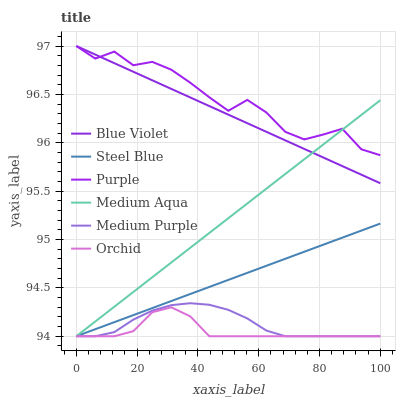Does Orchid have the minimum area under the curve?
Answer yes or no. Yes. Does Purple have the maximum area under the curve?
Answer yes or no. Yes. Does Steel Blue have the minimum area under the curve?
Answer yes or no. No. Does Steel Blue have the maximum area under the curve?
Answer yes or no. No. Is Medium Aqua the smoothest?
Answer yes or no. Yes. Is Purple the roughest?
Answer yes or no. Yes. Is Steel Blue the smoothest?
Answer yes or no. No. Is Steel Blue the roughest?
Answer yes or no. No. Does Blue Violet have the lowest value?
Answer yes or no. No. Does Blue Violet have the highest value?
Answer yes or no. Yes. Does Steel Blue have the highest value?
Answer yes or no. No. Is Steel Blue less than Purple?
Answer yes or no. Yes. Is Purple greater than Orchid?
Answer yes or no. Yes. Does Steel Blue intersect Medium Aqua?
Answer yes or no. Yes. Is Steel Blue less than Medium Aqua?
Answer yes or no. No. Is Steel Blue greater than Medium Aqua?
Answer yes or no. No. Does Steel Blue intersect Purple?
Answer yes or no. No. 